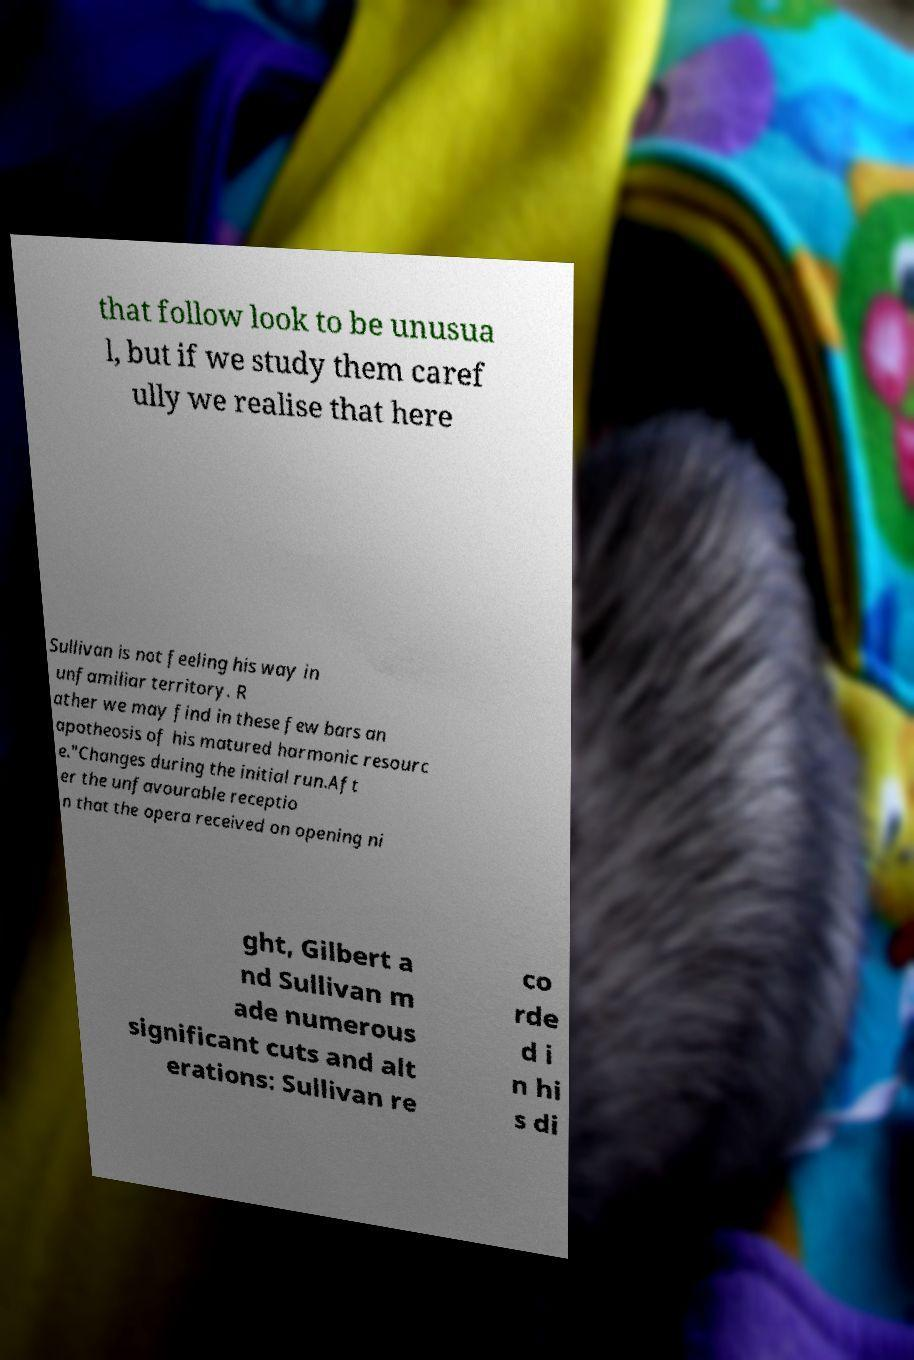There's text embedded in this image that I need extracted. Can you transcribe it verbatim? that follow look to be unusua l, but if we study them caref ully we realise that here Sullivan is not feeling his way in unfamiliar territory. R ather we may find in these few bars an apotheosis of his matured harmonic resourc e."Changes during the initial run.Aft er the unfavourable receptio n that the opera received on opening ni ght, Gilbert a nd Sullivan m ade numerous significant cuts and alt erations: Sullivan re co rde d i n hi s di 